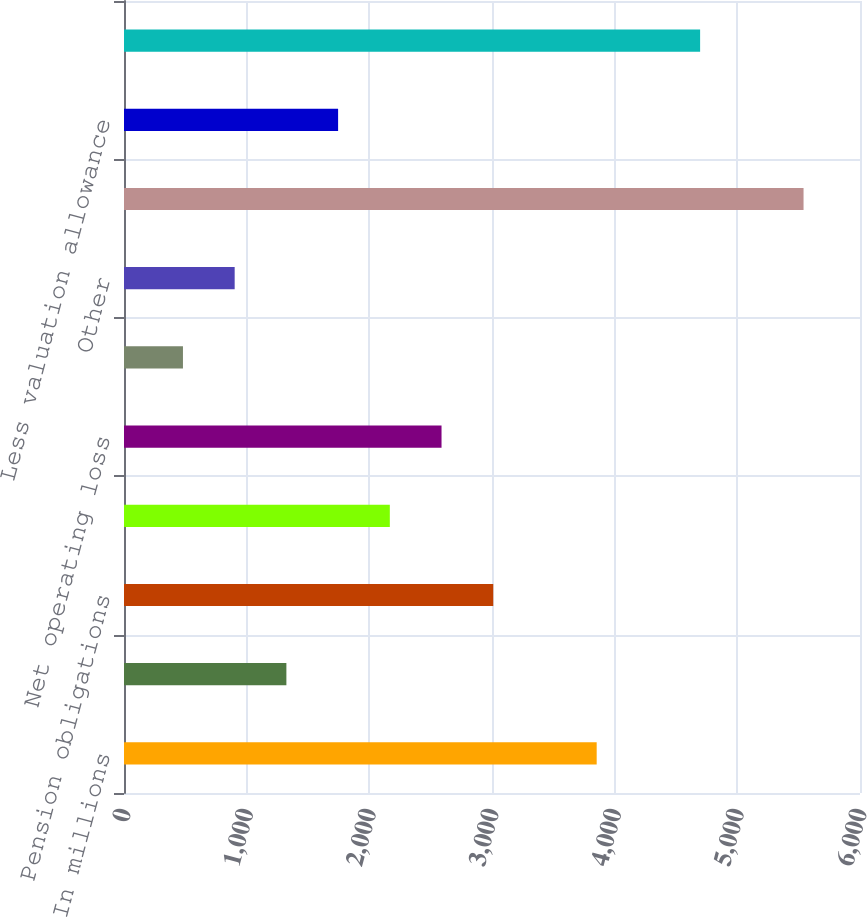Convert chart. <chart><loc_0><loc_0><loc_500><loc_500><bar_chart><fcel>In millions<fcel>Postretirement benefit<fcel>Pension obligations<fcel>Alternative minimum and other<fcel>Net operating loss<fcel>Compensation reserves<fcel>Other<fcel>Gross deferred income tax<fcel>Less valuation allowance<fcel>Net deferred income tax asset<nl><fcel>3853.4<fcel>1323.8<fcel>3010.2<fcel>2167<fcel>2588.6<fcel>480.6<fcel>902.2<fcel>5539.8<fcel>1745.4<fcel>4696.6<nl></chart> 